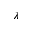Convert formula to latex. <formula><loc_0><loc_0><loc_500><loc_500>\lambda</formula> 